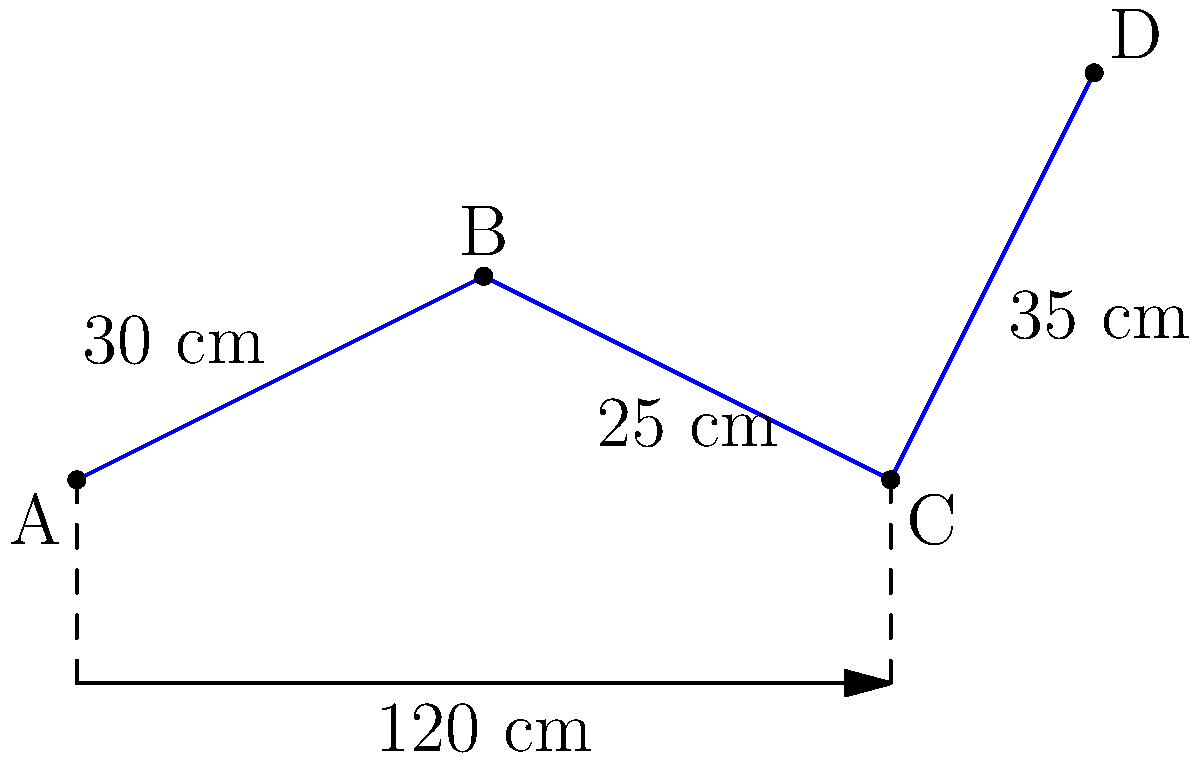In a fossil trackway, you've discovered a series of four dinosaur footprints (A, B, C, and D) in a line. The distances between the centers of consecutive footprints are 30 cm, 25 cm, and 35 cm, respectively. The total length of the trackway is 120 cm. If the footprints form a group under the operation of translation, what is the order of this group? To determine the order of the group formed by these footprints under translation, we need to follow these steps:

1. Understand the group operation: Translation in this context means moving from one footprint to another along the trackway.

2. Identify the elements of the group: The elements are the footprints A, B, C, and D.

3. Find the generator of the group: The smallest non-zero translation that, when repeated, can generate all elements of the group. In this case, it's the greatest common divisor (GCD) of all distances between footprints.

4. Calculate the GCD:
   GCD(30, 25, 35) = 5 cm

5. Determine the order of the group: The order is the number of times we need to apply the generator to return to the starting point. It's calculated by dividing the total length of the trackway by the GCD.

   Order = Total length / GCD
   Order = 120 cm / 5 cm = 24

Therefore, the order of the group is 24. This means that applying the 5 cm translation 24 times will bring us back to the starting point, cycling through all unique positions in the trackway.
Answer: 24 